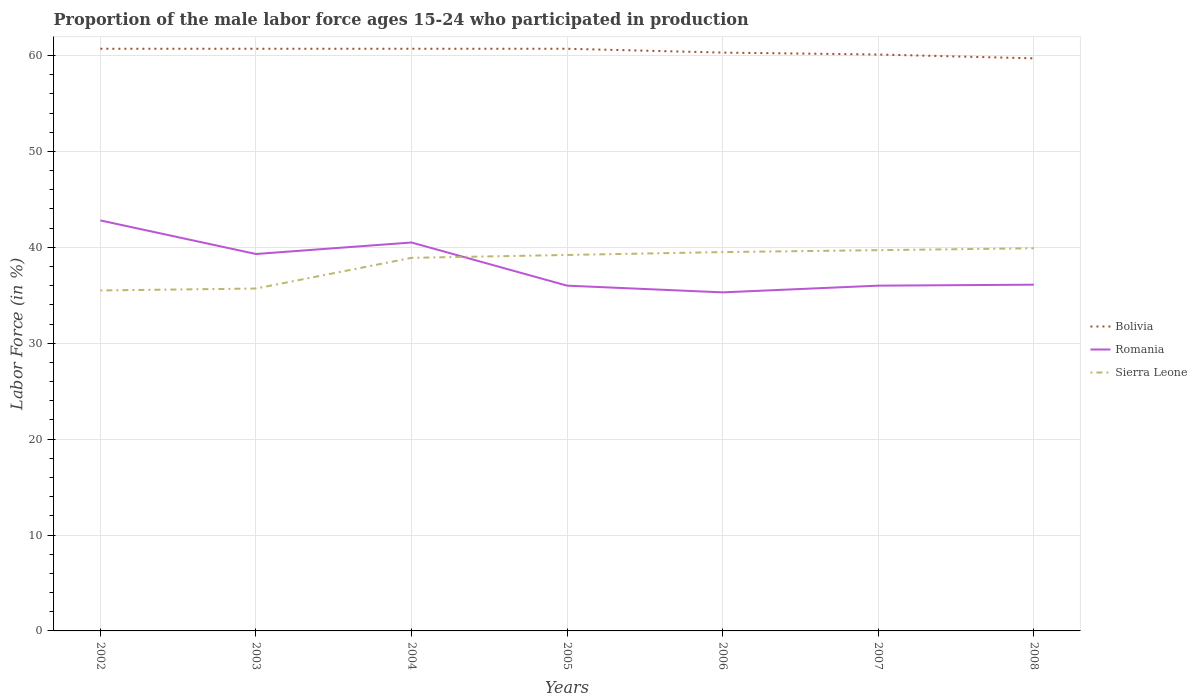How many different coloured lines are there?
Make the answer very short. 3. Does the line corresponding to Romania intersect with the line corresponding to Sierra Leone?
Offer a terse response. Yes. Is the number of lines equal to the number of legend labels?
Offer a very short reply. Yes. Across all years, what is the maximum proportion of the male labor force who participated in production in Romania?
Offer a terse response. 35.3. In which year was the proportion of the male labor force who participated in production in Sierra Leone maximum?
Ensure brevity in your answer.  2002. What is the total proportion of the male labor force who participated in production in Bolivia in the graph?
Provide a short and direct response. 1. What is the difference between the highest and the second highest proportion of the male labor force who participated in production in Sierra Leone?
Give a very brief answer. 4.4. Is the proportion of the male labor force who participated in production in Sierra Leone strictly greater than the proportion of the male labor force who participated in production in Bolivia over the years?
Ensure brevity in your answer.  Yes. How many lines are there?
Your answer should be very brief. 3. How many years are there in the graph?
Give a very brief answer. 7. What is the difference between two consecutive major ticks on the Y-axis?
Give a very brief answer. 10. Are the values on the major ticks of Y-axis written in scientific E-notation?
Provide a succinct answer. No. Does the graph contain grids?
Provide a short and direct response. Yes. Where does the legend appear in the graph?
Provide a succinct answer. Center right. How many legend labels are there?
Offer a terse response. 3. How are the legend labels stacked?
Provide a short and direct response. Vertical. What is the title of the graph?
Provide a short and direct response. Proportion of the male labor force ages 15-24 who participated in production. What is the Labor Force (in %) in Bolivia in 2002?
Ensure brevity in your answer.  60.7. What is the Labor Force (in %) of Romania in 2002?
Offer a terse response. 42.8. What is the Labor Force (in %) in Sierra Leone in 2002?
Offer a terse response. 35.5. What is the Labor Force (in %) of Bolivia in 2003?
Your response must be concise. 60.7. What is the Labor Force (in %) of Romania in 2003?
Offer a very short reply. 39.3. What is the Labor Force (in %) of Sierra Leone in 2003?
Your answer should be compact. 35.7. What is the Labor Force (in %) of Bolivia in 2004?
Offer a terse response. 60.7. What is the Labor Force (in %) in Romania in 2004?
Provide a succinct answer. 40.5. What is the Labor Force (in %) of Sierra Leone in 2004?
Make the answer very short. 38.9. What is the Labor Force (in %) of Bolivia in 2005?
Provide a short and direct response. 60.7. What is the Labor Force (in %) in Romania in 2005?
Ensure brevity in your answer.  36. What is the Labor Force (in %) of Sierra Leone in 2005?
Your answer should be very brief. 39.2. What is the Labor Force (in %) of Bolivia in 2006?
Provide a short and direct response. 60.3. What is the Labor Force (in %) in Romania in 2006?
Your answer should be very brief. 35.3. What is the Labor Force (in %) of Sierra Leone in 2006?
Your answer should be compact. 39.5. What is the Labor Force (in %) in Bolivia in 2007?
Keep it short and to the point. 60.1. What is the Labor Force (in %) in Sierra Leone in 2007?
Offer a very short reply. 39.7. What is the Labor Force (in %) in Bolivia in 2008?
Offer a very short reply. 59.7. What is the Labor Force (in %) in Romania in 2008?
Your answer should be compact. 36.1. What is the Labor Force (in %) in Sierra Leone in 2008?
Your response must be concise. 39.9. Across all years, what is the maximum Labor Force (in %) in Bolivia?
Make the answer very short. 60.7. Across all years, what is the maximum Labor Force (in %) in Romania?
Give a very brief answer. 42.8. Across all years, what is the maximum Labor Force (in %) in Sierra Leone?
Provide a succinct answer. 39.9. Across all years, what is the minimum Labor Force (in %) of Bolivia?
Provide a short and direct response. 59.7. Across all years, what is the minimum Labor Force (in %) in Romania?
Your response must be concise. 35.3. Across all years, what is the minimum Labor Force (in %) in Sierra Leone?
Offer a very short reply. 35.5. What is the total Labor Force (in %) of Bolivia in the graph?
Your answer should be very brief. 422.9. What is the total Labor Force (in %) in Romania in the graph?
Provide a succinct answer. 266. What is the total Labor Force (in %) in Sierra Leone in the graph?
Your answer should be very brief. 268.4. What is the difference between the Labor Force (in %) of Bolivia in 2002 and that in 2003?
Your answer should be very brief. 0. What is the difference between the Labor Force (in %) in Romania in 2002 and that in 2003?
Your answer should be compact. 3.5. What is the difference between the Labor Force (in %) in Bolivia in 2002 and that in 2004?
Offer a terse response. 0. What is the difference between the Labor Force (in %) of Sierra Leone in 2002 and that in 2004?
Provide a succinct answer. -3.4. What is the difference between the Labor Force (in %) in Bolivia in 2002 and that in 2005?
Your answer should be compact. 0. What is the difference between the Labor Force (in %) in Romania in 2002 and that in 2005?
Your response must be concise. 6.8. What is the difference between the Labor Force (in %) in Sierra Leone in 2002 and that in 2005?
Make the answer very short. -3.7. What is the difference between the Labor Force (in %) of Bolivia in 2002 and that in 2007?
Keep it short and to the point. 0.6. What is the difference between the Labor Force (in %) in Sierra Leone in 2002 and that in 2008?
Your answer should be very brief. -4.4. What is the difference between the Labor Force (in %) of Romania in 2003 and that in 2004?
Make the answer very short. -1.2. What is the difference between the Labor Force (in %) of Bolivia in 2003 and that in 2005?
Offer a very short reply. 0. What is the difference between the Labor Force (in %) in Romania in 2003 and that in 2006?
Offer a terse response. 4. What is the difference between the Labor Force (in %) of Bolivia in 2003 and that in 2007?
Offer a terse response. 0.6. What is the difference between the Labor Force (in %) in Romania in 2003 and that in 2007?
Your answer should be very brief. 3.3. What is the difference between the Labor Force (in %) of Bolivia in 2003 and that in 2008?
Give a very brief answer. 1. What is the difference between the Labor Force (in %) of Romania in 2003 and that in 2008?
Ensure brevity in your answer.  3.2. What is the difference between the Labor Force (in %) of Sierra Leone in 2003 and that in 2008?
Offer a terse response. -4.2. What is the difference between the Labor Force (in %) of Bolivia in 2004 and that in 2008?
Keep it short and to the point. 1. What is the difference between the Labor Force (in %) of Romania in 2004 and that in 2008?
Offer a terse response. 4.4. What is the difference between the Labor Force (in %) of Bolivia in 2005 and that in 2006?
Keep it short and to the point. 0.4. What is the difference between the Labor Force (in %) of Sierra Leone in 2005 and that in 2006?
Keep it short and to the point. -0.3. What is the difference between the Labor Force (in %) in Romania in 2005 and that in 2007?
Provide a succinct answer. 0. What is the difference between the Labor Force (in %) in Bolivia in 2005 and that in 2008?
Your answer should be very brief. 1. What is the difference between the Labor Force (in %) in Sierra Leone in 2005 and that in 2008?
Give a very brief answer. -0.7. What is the difference between the Labor Force (in %) of Sierra Leone in 2006 and that in 2007?
Ensure brevity in your answer.  -0.2. What is the difference between the Labor Force (in %) in Bolivia in 2006 and that in 2008?
Your response must be concise. 0.6. What is the difference between the Labor Force (in %) of Sierra Leone in 2006 and that in 2008?
Provide a succinct answer. -0.4. What is the difference between the Labor Force (in %) of Bolivia in 2007 and that in 2008?
Give a very brief answer. 0.4. What is the difference between the Labor Force (in %) in Romania in 2007 and that in 2008?
Make the answer very short. -0.1. What is the difference between the Labor Force (in %) in Sierra Leone in 2007 and that in 2008?
Give a very brief answer. -0.2. What is the difference between the Labor Force (in %) in Bolivia in 2002 and the Labor Force (in %) in Romania in 2003?
Give a very brief answer. 21.4. What is the difference between the Labor Force (in %) of Bolivia in 2002 and the Labor Force (in %) of Romania in 2004?
Offer a terse response. 20.2. What is the difference between the Labor Force (in %) in Bolivia in 2002 and the Labor Force (in %) in Sierra Leone in 2004?
Offer a terse response. 21.8. What is the difference between the Labor Force (in %) of Romania in 2002 and the Labor Force (in %) of Sierra Leone in 2004?
Your answer should be compact. 3.9. What is the difference between the Labor Force (in %) in Bolivia in 2002 and the Labor Force (in %) in Romania in 2005?
Provide a short and direct response. 24.7. What is the difference between the Labor Force (in %) of Bolivia in 2002 and the Labor Force (in %) of Romania in 2006?
Ensure brevity in your answer.  25.4. What is the difference between the Labor Force (in %) in Bolivia in 2002 and the Labor Force (in %) in Sierra Leone in 2006?
Give a very brief answer. 21.2. What is the difference between the Labor Force (in %) of Romania in 2002 and the Labor Force (in %) of Sierra Leone in 2006?
Provide a short and direct response. 3.3. What is the difference between the Labor Force (in %) in Bolivia in 2002 and the Labor Force (in %) in Romania in 2007?
Your response must be concise. 24.7. What is the difference between the Labor Force (in %) of Bolivia in 2002 and the Labor Force (in %) of Romania in 2008?
Provide a succinct answer. 24.6. What is the difference between the Labor Force (in %) in Bolivia in 2002 and the Labor Force (in %) in Sierra Leone in 2008?
Your answer should be very brief. 20.8. What is the difference between the Labor Force (in %) in Bolivia in 2003 and the Labor Force (in %) in Romania in 2004?
Provide a succinct answer. 20.2. What is the difference between the Labor Force (in %) in Bolivia in 2003 and the Labor Force (in %) in Sierra Leone in 2004?
Keep it short and to the point. 21.8. What is the difference between the Labor Force (in %) of Romania in 2003 and the Labor Force (in %) of Sierra Leone in 2004?
Provide a succinct answer. 0.4. What is the difference between the Labor Force (in %) in Bolivia in 2003 and the Labor Force (in %) in Romania in 2005?
Provide a succinct answer. 24.7. What is the difference between the Labor Force (in %) in Bolivia in 2003 and the Labor Force (in %) in Romania in 2006?
Provide a succinct answer. 25.4. What is the difference between the Labor Force (in %) in Bolivia in 2003 and the Labor Force (in %) in Sierra Leone in 2006?
Your answer should be compact. 21.2. What is the difference between the Labor Force (in %) of Bolivia in 2003 and the Labor Force (in %) of Romania in 2007?
Make the answer very short. 24.7. What is the difference between the Labor Force (in %) in Bolivia in 2003 and the Labor Force (in %) in Sierra Leone in 2007?
Offer a very short reply. 21. What is the difference between the Labor Force (in %) of Romania in 2003 and the Labor Force (in %) of Sierra Leone in 2007?
Give a very brief answer. -0.4. What is the difference between the Labor Force (in %) of Bolivia in 2003 and the Labor Force (in %) of Romania in 2008?
Offer a very short reply. 24.6. What is the difference between the Labor Force (in %) of Bolivia in 2003 and the Labor Force (in %) of Sierra Leone in 2008?
Offer a terse response. 20.8. What is the difference between the Labor Force (in %) of Bolivia in 2004 and the Labor Force (in %) of Romania in 2005?
Keep it short and to the point. 24.7. What is the difference between the Labor Force (in %) of Romania in 2004 and the Labor Force (in %) of Sierra Leone in 2005?
Your response must be concise. 1.3. What is the difference between the Labor Force (in %) of Bolivia in 2004 and the Labor Force (in %) of Romania in 2006?
Keep it short and to the point. 25.4. What is the difference between the Labor Force (in %) of Bolivia in 2004 and the Labor Force (in %) of Sierra Leone in 2006?
Your response must be concise. 21.2. What is the difference between the Labor Force (in %) of Romania in 2004 and the Labor Force (in %) of Sierra Leone in 2006?
Offer a terse response. 1. What is the difference between the Labor Force (in %) of Bolivia in 2004 and the Labor Force (in %) of Romania in 2007?
Offer a terse response. 24.7. What is the difference between the Labor Force (in %) in Romania in 2004 and the Labor Force (in %) in Sierra Leone in 2007?
Offer a terse response. 0.8. What is the difference between the Labor Force (in %) in Bolivia in 2004 and the Labor Force (in %) in Romania in 2008?
Offer a terse response. 24.6. What is the difference between the Labor Force (in %) in Bolivia in 2004 and the Labor Force (in %) in Sierra Leone in 2008?
Give a very brief answer. 20.8. What is the difference between the Labor Force (in %) in Romania in 2004 and the Labor Force (in %) in Sierra Leone in 2008?
Your response must be concise. 0.6. What is the difference between the Labor Force (in %) in Bolivia in 2005 and the Labor Force (in %) in Romania in 2006?
Make the answer very short. 25.4. What is the difference between the Labor Force (in %) of Bolivia in 2005 and the Labor Force (in %) of Sierra Leone in 2006?
Offer a terse response. 21.2. What is the difference between the Labor Force (in %) of Bolivia in 2005 and the Labor Force (in %) of Romania in 2007?
Ensure brevity in your answer.  24.7. What is the difference between the Labor Force (in %) of Bolivia in 2005 and the Labor Force (in %) of Sierra Leone in 2007?
Make the answer very short. 21. What is the difference between the Labor Force (in %) in Romania in 2005 and the Labor Force (in %) in Sierra Leone in 2007?
Your answer should be very brief. -3.7. What is the difference between the Labor Force (in %) in Bolivia in 2005 and the Labor Force (in %) in Romania in 2008?
Your response must be concise. 24.6. What is the difference between the Labor Force (in %) in Bolivia in 2005 and the Labor Force (in %) in Sierra Leone in 2008?
Your answer should be very brief. 20.8. What is the difference between the Labor Force (in %) of Romania in 2005 and the Labor Force (in %) of Sierra Leone in 2008?
Provide a succinct answer. -3.9. What is the difference between the Labor Force (in %) of Bolivia in 2006 and the Labor Force (in %) of Romania in 2007?
Keep it short and to the point. 24.3. What is the difference between the Labor Force (in %) in Bolivia in 2006 and the Labor Force (in %) in Sierra Leone in 2007?
Offer a terse response. 20.6. What is the difference between the Labor Force (in %) of Bolivia in 2006 and the Labor Force (in %) of Romania in 2008?
Give a very brief answer. 24.2. What is the difference between the Labor Force (in %) in Bolivia in 2006 and the Labor Force (in %) in Sierra Leone in 2008?
Provide a succinct answer. 20.4. What is the difference between the Labor Force (in %) of Bolivia in 2007 and the Labor Force (in %) of Sierra Leone in 2008?
Ensure brevity in your answer.  20.2. What is the difference between the Labor Force (in %) in Romania in 2007 and the Labor Force (in %) in Sierra Leone in 2008?
Keep it short and to the point. -3.9. What is the average Labor Force (in %) of Bolivia per year?
Your answer should be very brief. 60.41. What is the average Labor Force (in %) in Romania per year?
Your answer should be very brief. 38. What is the average Labor Force (in %) of Sierra Leone per year?
Your response must be concise. 38.34. In the year 2002, what is the difference between the Labor Force (in %) in Bolivia and Labor Force (in %) in Sierra Leone?
Offer a very short reply. 25.2. In the year 2002, what is the difference between the Labor Force (in %) of Romania and Labor Force (in %) of Sierra Leone?
Offer a very short reply. 7.3. In the year 2003, what is the difference between the Labor Force (in %) in Bolivia and Labor Force (in %) in Romania?
Ensure brevity in your answer.  21.4. In the year 2004, what is the difference between the Labor Force (in %) of Bolivia and Labor Force (in %) of Romania?
Give a very brief answer. 20.2. In the year 2004, what is the difference between the Labor Force (in %) of Bolivia and Labor Force (in %) of Sierra Leone?
Offer a terse response. 21.8. In the year 2005, what is the difference between the Labor Force (in %) of Bolivia and Labor Force (in %) of Romania?
Make the answer very short. 24.7. In the year 2005, what is the difference between the Labor Force (in %) in Romania and Labor Force (in %) in Sierra Leone?
Make the answer very short. -3.2. In the year 2006, what is the difference between the Labor Force (in %) in Bolivia and Labor Force (in %) in Romania?
Offer a terse response. 25. In the year 2006, what is the difference between the Labor Force (in %) in Bolivia and Labor Force (in %) in Sierra Leone?
Offer a very short reply. 20.8. In the year 2006, what is the difference between the Labor Force (in %) of Romania and Labor Force (in %) of Sierra Leone?
Your answer should be compact. -4.2. In the year 2007, what is the difference between the Labor Force (in %) of Bolivia and Labor Force (in %) of Romania?
Your answer should be very brief. 24.1. In the year 2007, what is the difference between the Labor Force (in %) in Bolivia and Labor Force (in %) in Sierra Leone?
Make the answer very short. 20.4. In the year 2008, what is the difference between the Labor Force (in %) in Bolivia and Labor Force (in %) in Romania?
Your answer should be compact. 23.6. In the year 2008, what is the difference between the Labor Force (in %) of Bolivia and Labor Force (in %) of Sierra Leone?
Ensure brevity in your answer.  19.8. In the year 2008, what is the difference between the Labor Force (in %) of Romania and Labor Force (in %) of Sierra Leone?
Offer a very short reply. -3.8. What is the ratio of the Labor Force (in %) in Romania in 2002 to that in 2003?
Keep it short and to the point. 1.09. What is the ratio of the Labor Force (in %) of Sierra Leone in 2002 to that in 2003?
Give a very brief answer. 0.99. What is the ratio of the Labor Force (in %) of Bolivia in 2002 to that in 2004?
Provide a short and direct response. 1. What is the ratio of the Labor Force (in %) in Romania in 2002 to that in 2004?
Provide a succinct answer. 1.06. What is the ratio of the Labor Force (in %) of Sierra Leone in 2002 to that in 2004?
Offer a terse response. 0.91. What is the ratio of the Labor Force (in %) in Bolivia in 2002 to that in 2005?
Your answer should be compact. 1. What is the ratio of the Labor Force (in %) of Romania in 2002 to that in 2005?
Provide a succinct answer. 1.19. What is the ratio of the Labor Force (in %) in Sierra Leone in 2002 to that in 2005?
Your answer should be very brief. 0.91. What is the ratio of the Labor Force (in %) of Bolivia in 2002 to that in 2006?
Your answer should be compact. 1.01. What is the ratio of the Labor Force (in %) of Romania in 2002 to that in 2006?
Ensure brevity in your answer.  1.21. What is the ratio of the Labor Force (in %) of Sierra Leone in 2002 to that in 2006?
Your response must be concise. 0.9. What is the ratio of the Labor Force (in %) in Bolivia in 2002 to that in 2007?
Offer a terse response. 1.01. What is the ratio of the Labor Force (in %) of Romania in 2002 to that in 2007?
Your answer should be very brief. 1.19. What is the ratio of the Labor Force (in %) in Sierra Leone in 2002 to that in 2007?
Make the answer very short. 0.89. What is the ratio of the Labor Force (in %) of Bolivia in 2002 to that in 2008?
Provide a short and direct response. 1.02. What is the ratio of the Labor Force (in %) of Romania in 2002 to that in 2008?
Make the answer very short. 1.19. What is the ratio of the Labor Force (in %) in Sierra Leone in 2002 to that in 2008?
Provide a succinct answer. 0.89. What is the ratio of the Labor Force (in %) of Romania in 2003 to that in 2004?
Your answer should be very brief. 0.97. What is the ratio of the Labor Force (in %) of Sierra Leone in 2003 to that in 2004?
Offer a very short reply. 0.92. What is the ratio of the Labor Force (in %) of Romania in 2003 to that in 2005?
Give a very brief answer. 1.09. What is the ratio of the Labor Force (in %) of Sierra Leone in 2003 to that in 2005?
Provide a succinct answer. 0.91. What is the ratio of the Labor Force (in %) in Bolivia in 2003 to that in 2006?
Make the answer very short. 1.01. What is the ratio of the Labor Force (in %) in Romania in 2003 to that in 2006?
Your answer should be compact. 1.11. What is the ratio of the Labor Force (in %) of Sierra Leone in 2003 to that in 2006?
Make the answer very short. 0.9. What is the ratio of the Labor Force (in %) of Romania in 2003 to that in 2007?
Give a very brief answer. 1.09. What is the ratio of the Labor Force (in %) of Sierra Leone in 2003 to that in 2007?
Your response must be concise. 0.9. What is the ratio of the Labor Force (in %) of Bolivia in 2003 to that in 2008?
Provide a succinct answer. 1.02. What is the ratio of the Labor Force (in %) of Romania in 2003 to that in 2008?
Offer a terse response. 1.09. What is the ratio of the Labor Force (in %) of Sierra Leone in 2003 to that in 2008?
Your response must be concise. 0.89. What is the ratio of the Labor Force (in %) in Bolivia in 2004 to that in 2005?
Offer a very short reply. 1. What is the ratio of the Labor Force (in %) in Romania in 2004 to that in 2005?
Keep it short and to the point. 1.12. What is the ratio of the Labor Force (in %) of Bolivia in 2004 to that in 2006?
Offer a very short reply. 1.01. What is the ratio of the Labor Force (in %) of Romania in 2004 to that in 2006?
Make the answer very short. 1.15. What is the ratio of the Labor Force (in %) of Sierra Leone in 2004 to that in 2006?
Your answer should be very brief. 0.98. What is the ratio of the Labor Force (in %) in Sierra Leone in 2004 to that in 2007?
Your answer should be compact. 0.98. What is the ratio of the Labor Force (in %) of Bolivia in 2004 to that in 2008?
Ensure brevity in your answer.  1.02. What is the ratio of the Labor Force (in %) in Romania in 2004 to that in 2008?
Provide a short and direct response. 1.12. What is the ratio of the Labor Force (in %) in Sierra Leone in 2004 to that in 2008?
Make the answer very short. 0.97. What is the ratio of the Labor Force (in %) of Bolivia in 2005 to that in 2006?
Give a very brief answer. 1.01. What is the ratio of the Labor Force (in %) of Romania in 2005 to that in 2006?
Offer a very short reply. 1.02. What is the ratio of the Labor Force (in %) in Sierra Leone in 2005 to that in 2007?
Offer a terse response. 0.99. What is the ratio of the Labor Force (in %) of Bolivia in 2005 to that in 2008?
Your answer should be very brief. 1.02. What is the ratio of the Labor Force (in %) in Romania in 2005 to that in 2008?
Provide a succinct answer. 1. What is the ratio of the Labor Force (in %) of Sierra Leone in 2005 to that in 2008?
Your answer should be very brief. 0.98. What is the ratio of the Labor Force (in %) in Romania in 2006 to that in 2007?
Your answer should be very brief. 0.98. What is the ratio of the Labor Force (in %) in Sierra Leone in 2006 to that in 2007?
Your answer should be compact. 0.99. What is the ratio of the Labor Force (in %) of Bolivia in 2006 to that in 2008?
Offer a terse response. 1.01. What is the ratio of the Labor Force (in %) in Romania in 2006 to that in 2008?
Make the answer very short. 0.98. What is the ratio of the Labor Force (in %) of Sierra Leone in 2006 to that in 2008?
Offer a terse response. 0.99. What is the ratio of the Labor Force (in %) of Bolivia in 2007 to that in 2008?
Offer a very short reply. 1.01. What is the ratio of the Labor Force (in %) of Romania in 2007 to that in 2008?
Provide a short and direct response. 1. What is the difference between the highest and the second highest Labor Force (in %) in Bolivia?
Make the answer very short. 0. What is the difference between the highest and the second highest Labor Force (in %) in Sierra Leone?
Provide a short and direct response. 0.2. What is the difference between the highest and the lowest Labor Force (in %) of Bolivia?
Give a very brief answer. 1. What is the difference between the highest and the lowest Labor Force (in %) of Sierra Leone?
Your answer should be very brief. 4.4. 